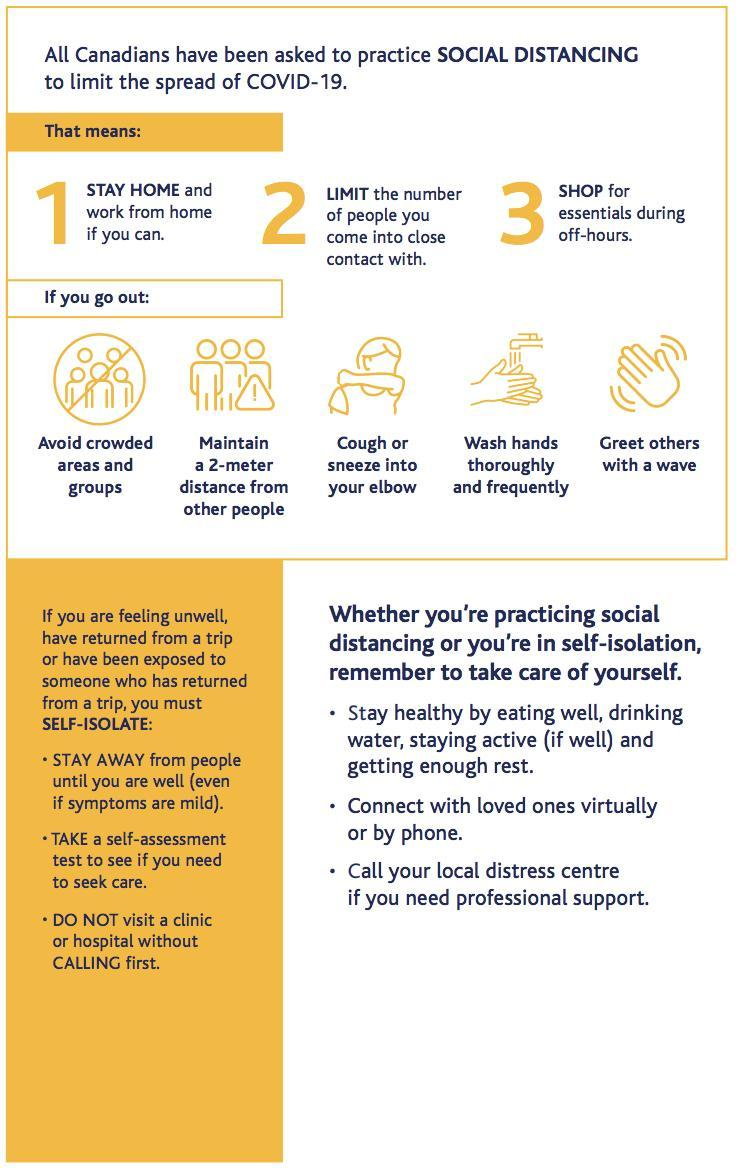How many steps to be followed to self-isolate
Answer the question with a short phrase. 3 Who should we approach for professional support local distress centre Where should we cough or sneeze into elbow What is the best time to shop during off-hours How should be greet others with a wave 